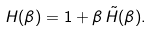Convert formula to latex. <formula><loc_0><loc_0><loc_500><loc_500>H ( \beta ) = 1 + \beta \, \tilde { H } ( \beta ) .</formula> 